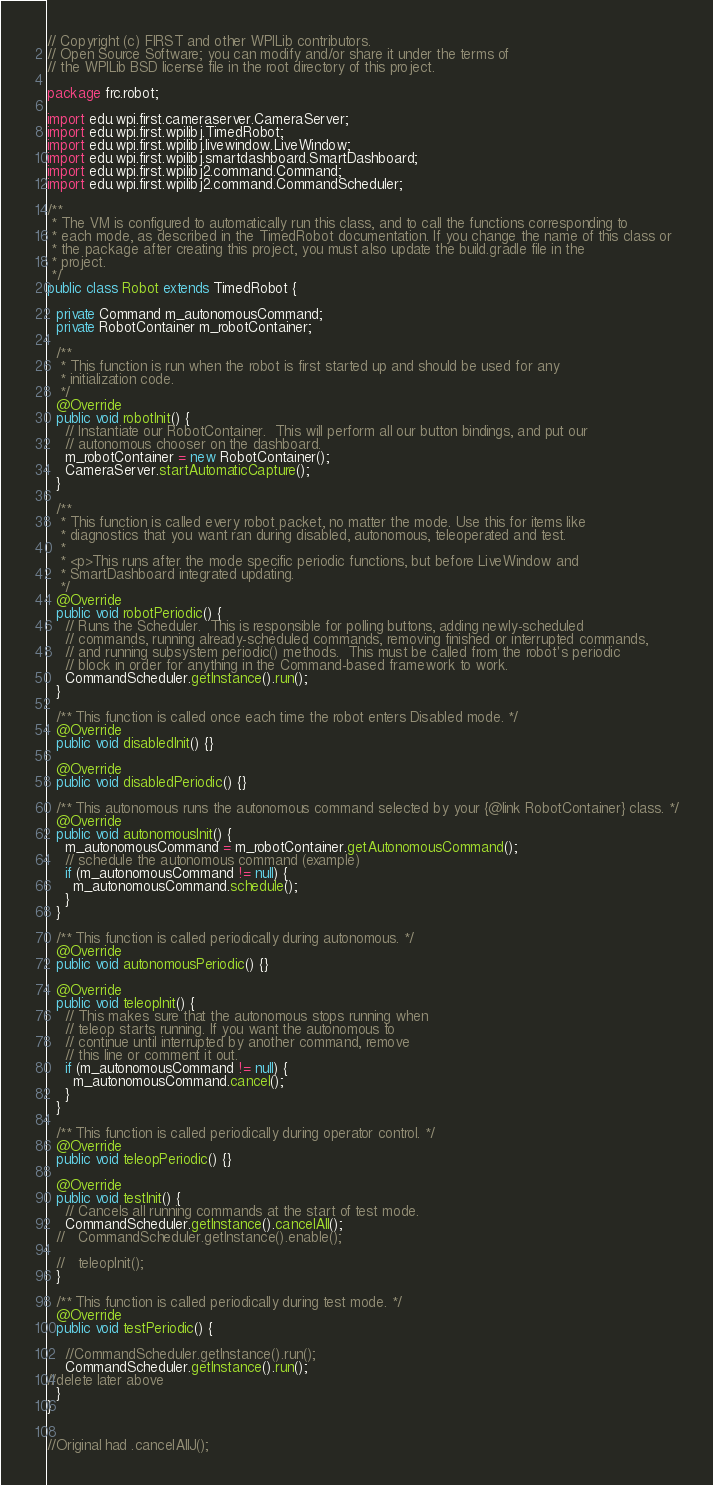<code> <loc_0><loc_0><loc_500><loc_500><_Java_>// Copyright (c) FIRST and other WPILib contributors.
// Open Source Software; you can modify and/or share it under the terms of
// the WPILib BSD license file in the root directory of this project.

package frc.robot;

import edu.wpi.first.cameraserver.CameraServer;
import edu.wpi.first.wpilibj.TimedRobot;
import edu.wpi.first.wpilibj.livewindow.LiveWindow;
import edu.wpi.first.wpilibj.smartdashboard.SmartDashboard;
import edu.wpi.first.wpilibj2.command.Command;
import edu.wpi.first.wpilibj2.command.CommandScheduler;

/**
 * The VM is configured to automatically run this class, and to call the functions corresponding to
 * each mode, as described in the TimedRobot documentation. If you change the name of this class or
 * the package after creating this project, you must also update the build.gradle file in the
 * project.
 */
public class Robot extends TimedRobot {

  private Command m_autonomousCommand;
  private RobotContainer m_robotContainer;

  /**
   * This function is run when the robot is first started up and should be used for any
   * initialization code.
   */
  @Override
  public void robotInit() {
    // Instantiate our RobotContainer.  This will perform all our button bindings, and put our
    // autonomous chooser on the dashboard.
    m_robotContainer = new RobotContainer();
    CameraServer.startAutomaticCapture();
  }

  /**
   * This function is called every robot packet, no matter the mode. Use this for items like
   * diagnostics that you want ran during disabled, autonomous, teleoperated and test.
   *
   * <p>This runs after the mode specific periodic functions, but before LiveWindow and
   * SmartDashboard integrated updating.
   */
  @Override
  public void robotPeriodic() {
    // Runs the Scheduler.  This is responsible for polling buttons, adding newly-scheduled
    // commands, running already-scheduled commands, removing finished or interrupted commands,
    // and running subsystem periodic() methods.  This must be called from the robot's periodic
    // block in order for anything in the Command-based framework to work.
    CommandScheduler.getInstance().run();
  }

  /** This function is called once each time the robot enters Disabled mode. */
  @Override
  public void disabledInit() {}

  @Override
  public void disabledPeriodic() {}

  /** This autonomous runs the autonomous command selected by your {@link RobotContainer} class. */
  @Override
  public void autonomousInit() {
    m_autonomousCommand = m_robotContainer.getAutonomousCommand();
    // schedule the autonomous command (example)
    if (m_autonomousCommand != null) {
      m_autonomousCommand.schedule();
    }
  }

  /** This function is called periodically during autonomous. */
  @Override
  public void autonomousPeriodic() {}

  @Override
  public void teleopInit() {
    // This makes sure that the autonomous stops running when
    // teleop starts running. If you want the autonomous to
    // continue until interrupted by another command, remove
    // this line or comment it out.
    if (m_autonomousCommand != null) {
      m_autonomousCommand.cancel();
    }
  }

  /** This function is called periodically during operator control. */
  @Override
  public void teleopPeriodic() {}

  @Override
  public void testInit() {
    // Cancels all running commands at the start of test mode.
    CommandScheduler.getInstance().cancelAll();
  //   CommandScheduler.getInstance().enable();

  //   teleopInit();
  }

  /** This function is called periodically during test mode. */
  @Override
  public void testPeriodic() {

    //CommandScheduler.getInstance().run();
    CommandScheduler.getInstance().run();
//delete later above
  }
}


//Original had .cancelAllJ();</code> 